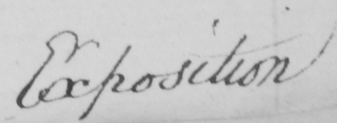Can you tell me what this handwritten text says? Exposition 